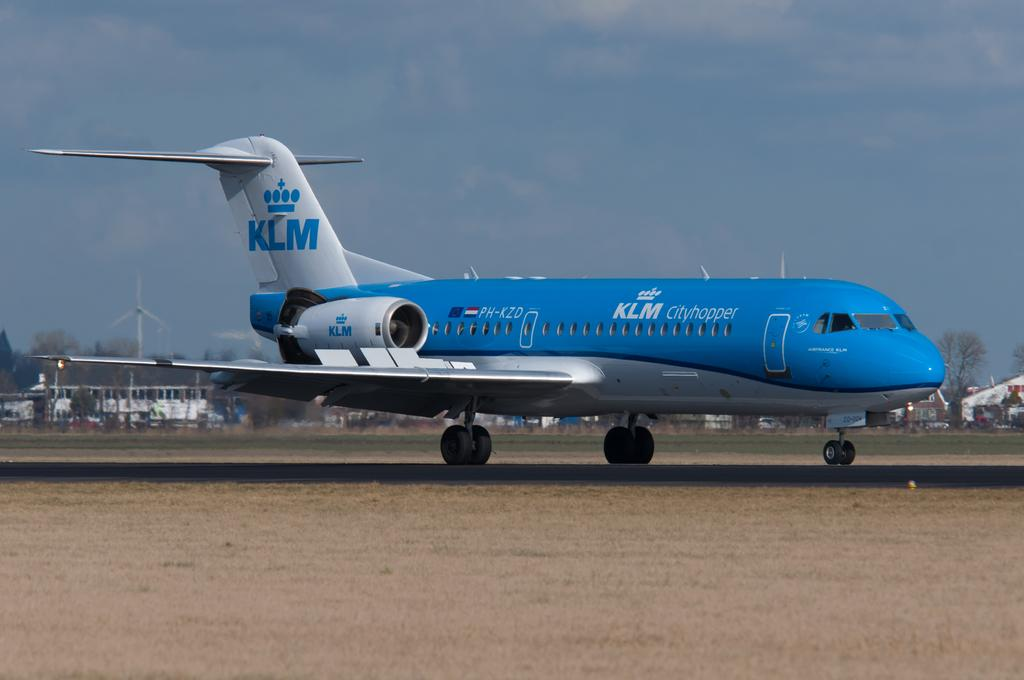Provide a one-sentence caption for the provided image. A blue and white KLM jet is on the ground. 